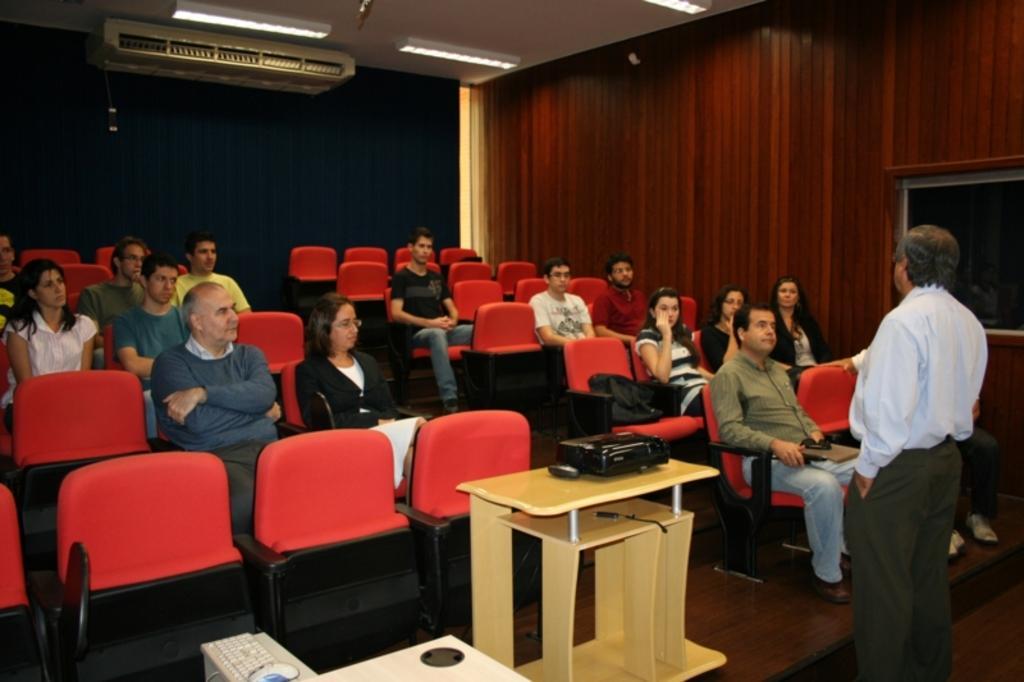Can you describe this image briefly? This is the picture of inside of the room. There are group of people sitting on the chair and at the right side of the image there is a person standing and there is a projector on the table. At the top there are lights. 